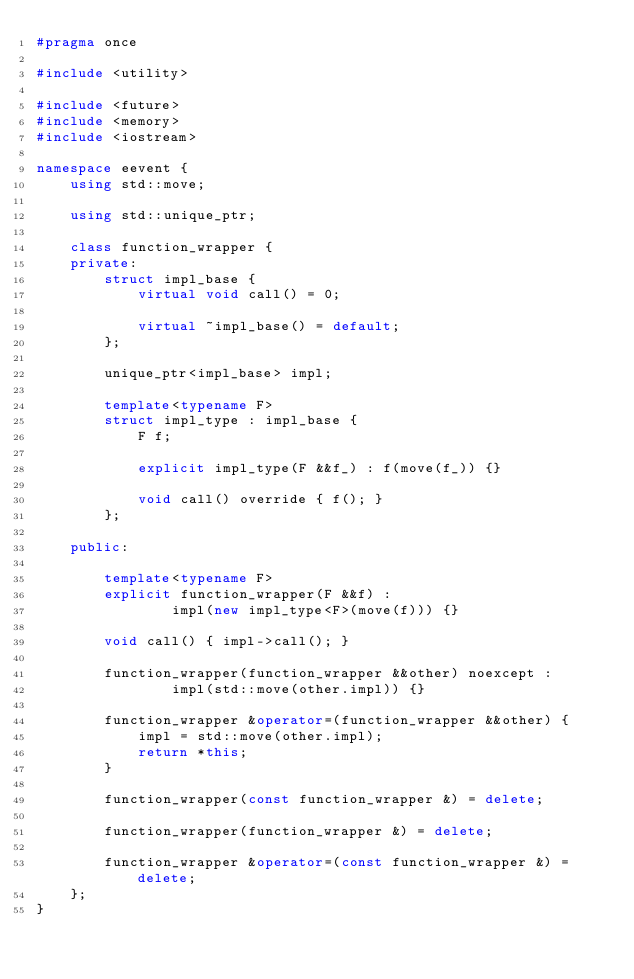Convert code to text. <code><loc_0><loc_0><loc_500><loc_500><_C++_>#pragma once

#include <utility>

#include <future>
#include <memory>
#include <iostream>

namespace eevent {
    using std::move;

    using std::unique_ptr;

    class function_wrapper {
    private:
        struct impl_base {
            virtual void call() = 0;

            virtual ~impl_base() = default;
        };

        unique_ptr<impl_base> impl;

        template<typename F>
        struct impl_type : impl_base {
            F f;

            explicit impl_type(F &&f_) : f(move(f_)) {}

            void call() override { f(); }
        };

    public:

        template<typename F>
        explicit function_wrapper(F &&f) :
                impl(new impl_type<F>(move(f))) {}

        void call() { impl->call(); }

        function_wrapper(function_wrapper &&other) noexcept :
                impl(std::move(other.impl)) {}

        function_wrapper &operator=(function_wrapper &&other) {
            impl = std::move(other.impl);
            return *this;
        }

        function_wrapper(const function_wrapper &) = delete;

        function_wrapper(function_wrapper &) = delete;

        function_wrapper &operator=(const function_wrapper &) = delete;
    };
}</code> 